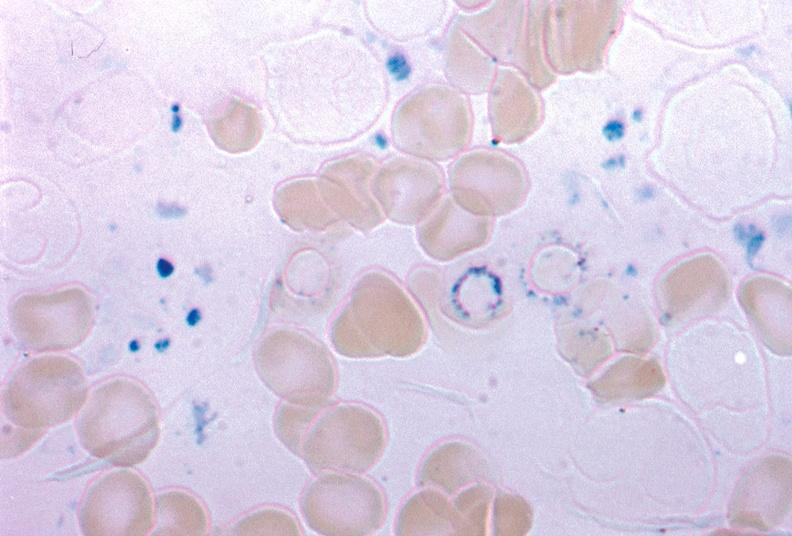s bone marrow present?
Answer the question using a single word or phrase. Yes 